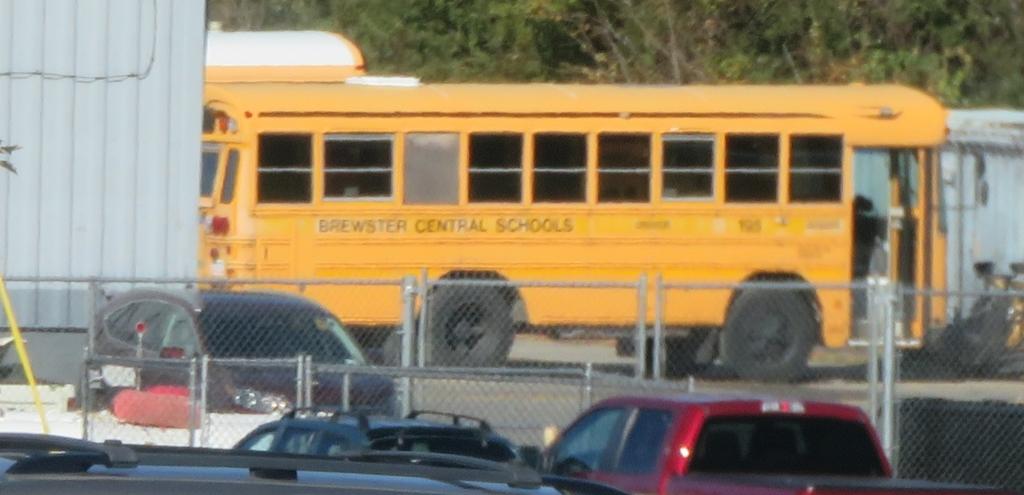What school district does this bus service?
Your answer should be compact. Brewster central. Is the school bus from brewster central schools?
Your answer should be very brief. Yes. 